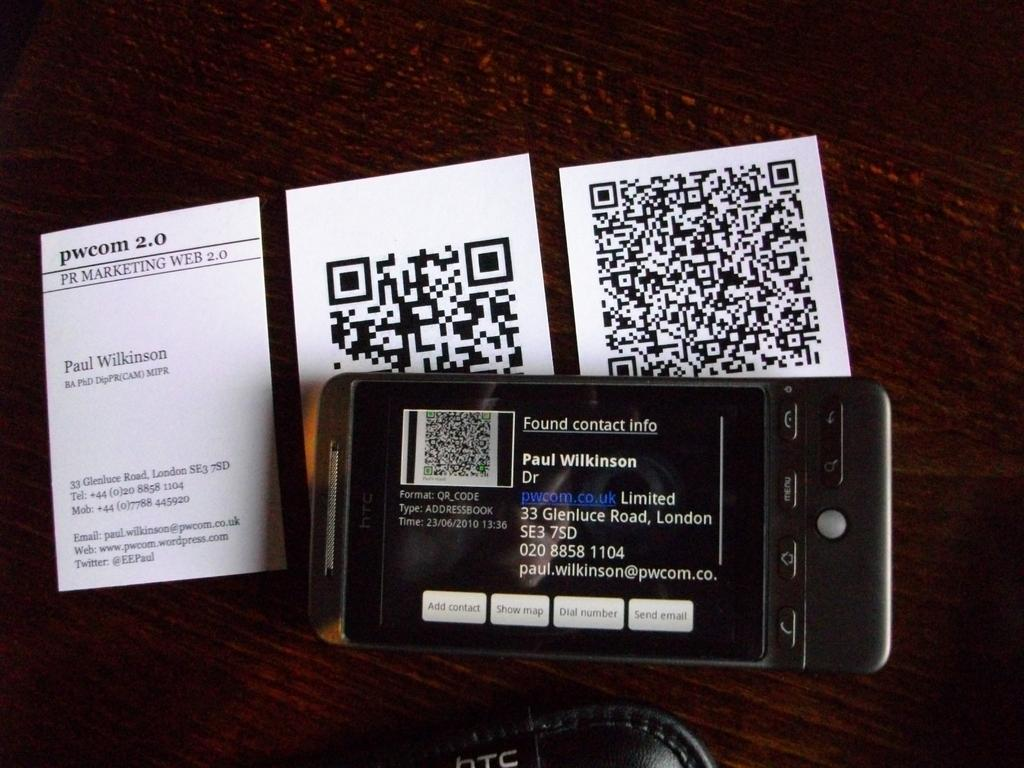<image>
Offer a succinct explanation of the picture presented. a phone on its side with the name Paul Wilkinson on it 